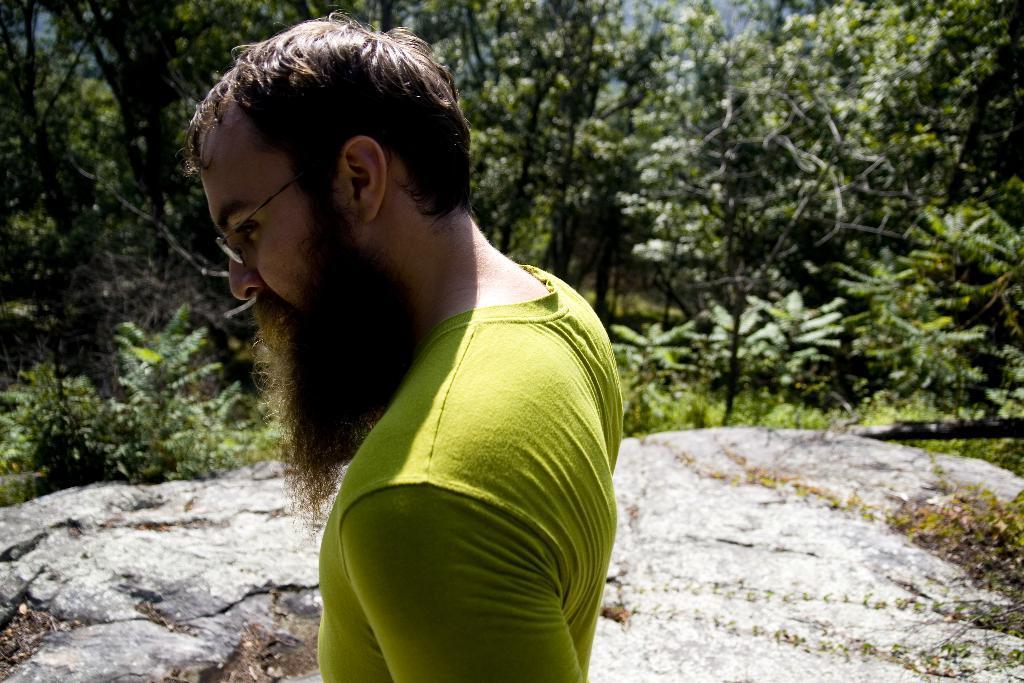Please provide a concise description of this image. In this picture I can observe a man in the middle of the picture. He is wearing green color T shirt. In the background I can observe trees. 